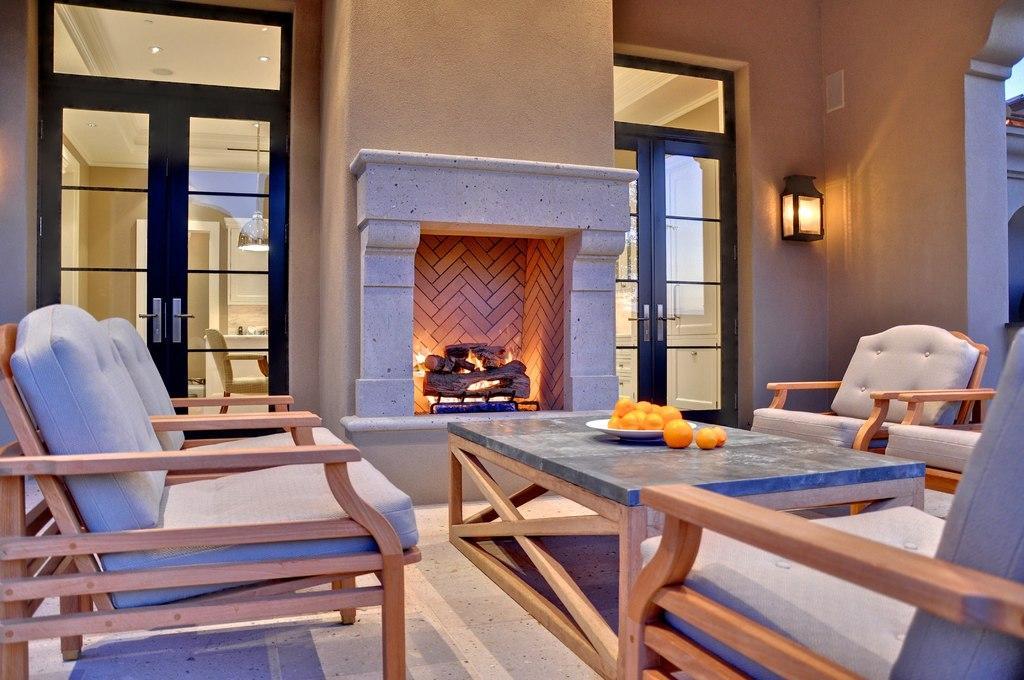Please provide a concise description of this image. In this image there are empty chairs and table, on top of the table there are fruits on a plate, in front of the table there is wood in the fireplace, beside the fireplace there are two glass doors connecting to another room, beside the door there is a lamp, in the other room there are chairs and wardrobes. 